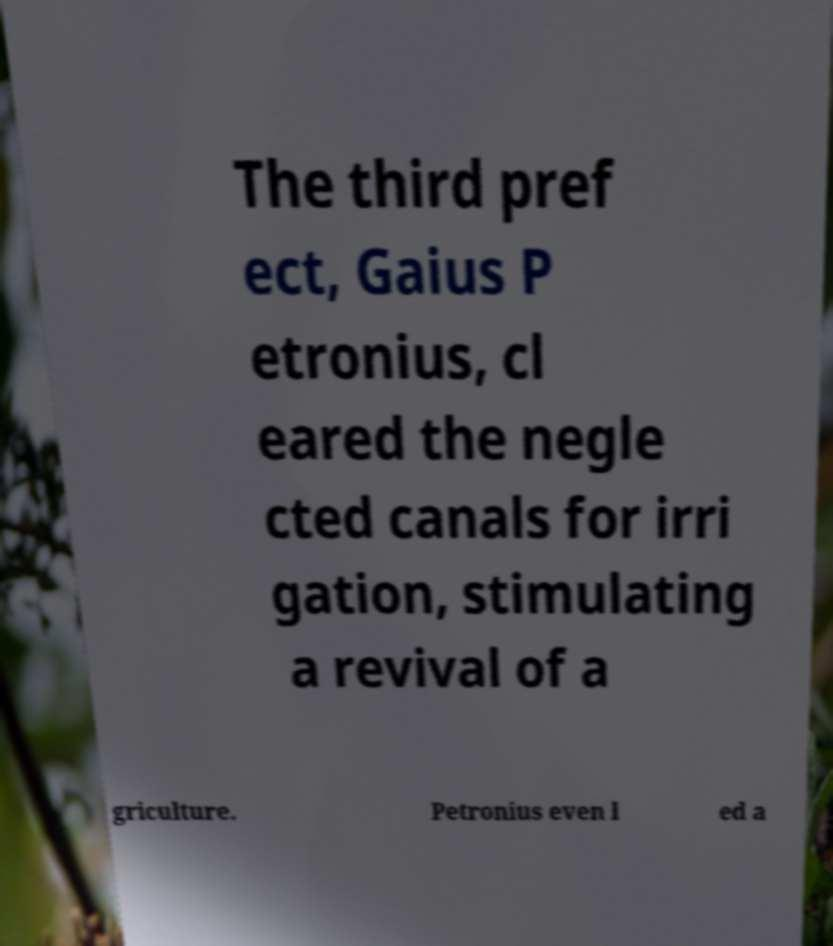I need the written content from this picture converted into text. Can you do that? The third pref ect, Gaius P etronius, cl eared the negle cted canals for irri gation, stimulating a revival of a griculture. Petronius even l ed a 